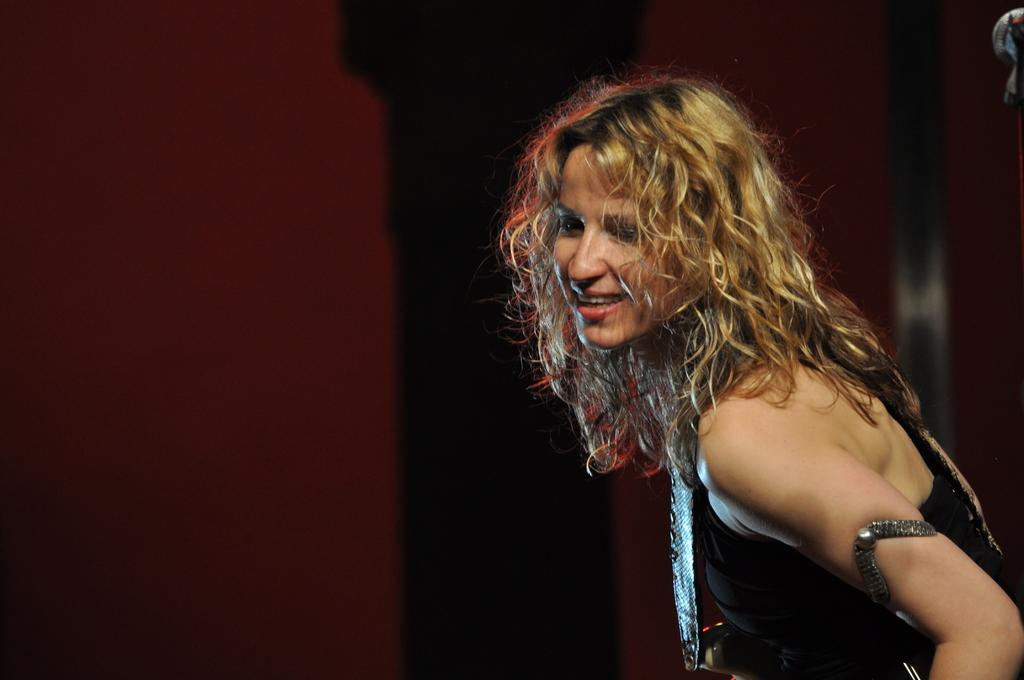Who is present in the image? There is a woman in the image. What is the woman's facial expression? The woman is smiling. What type of fog can be seen in the image? There is no fog present in the image; it only features a woman who is smiling. 